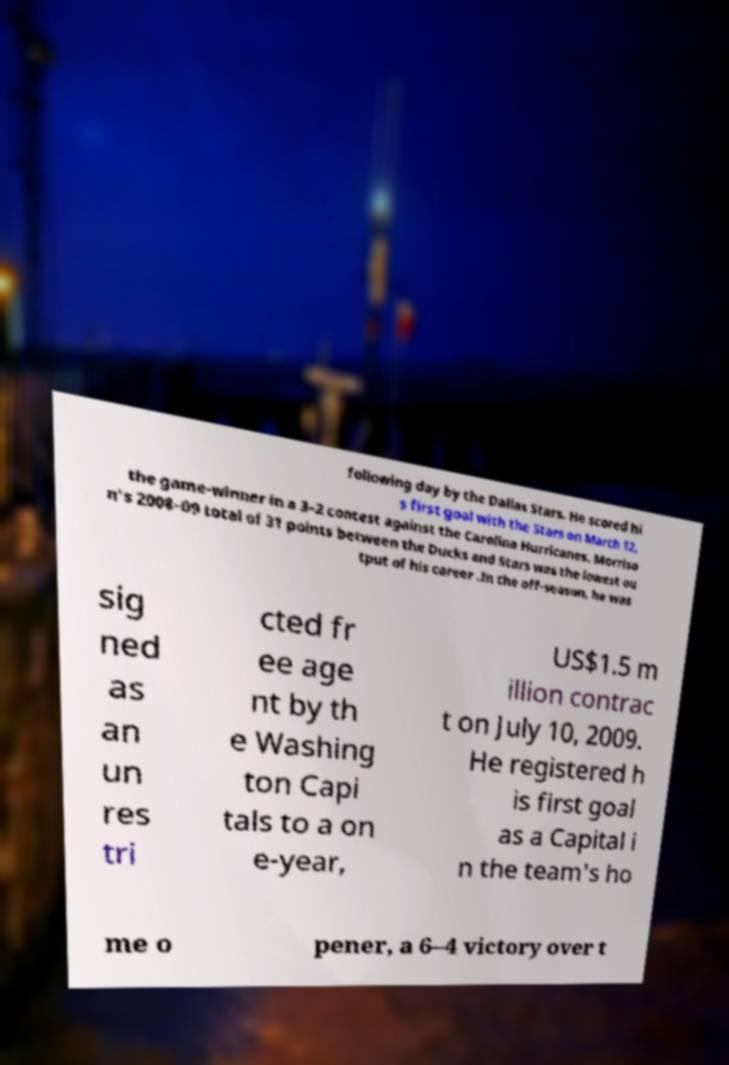Could you assist in decoding the text presented in this image and type it out clearly? following day by the Dallas Stars. He scored hi s first goal with the Stars on March 12, the game-winner in a 3–2 contest against the Carolina Hurricanes. Morriso n's 2008–09 total of 31 points between the Ducks and Stars was the lowest ou tput of his career .In the off-season, he was sig ned as an un res tri cted fr ee age nt by th e Washing ton Capi tals to a on e-year, US$1.5 m illion contrac t on July 10, 2009. He registered h is first goal as a Capital i n the team's ho me o pener, a 6–4 victory over t 